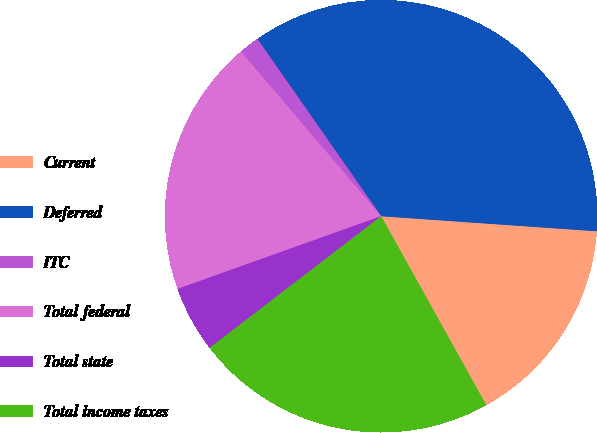<chart> <loc_0><loc_0><loc_500><loc_500><pie_chart><fcel>Current<fcel>Deferred<fcel>ITC<fcel>Total federal<fcel>Total state<fcel>Total income taxes<nl><fcel>15.81%<fcel>35.81%<fcel>1.53%<fcel>19.23%<fcel>4.96%<fcel>22.66%<nl></chart> 